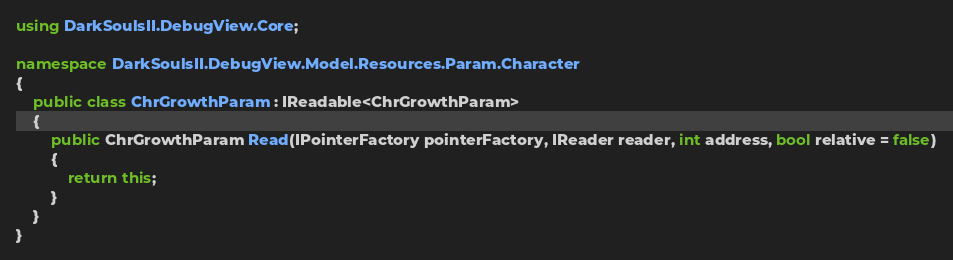Convert code to text. <code><loc_0><loc_0><loc_500><loc_500><_C#_>using DarkSoulsII.DebugView.Core;

namespace DarkSoulsII.DebugView.Model.Resources.Param.Character
{
    public class ChrGrowthParam : IReadable<ChrGrowthParam>
    {
        public ChrGrowthParam Read(IPointerFactory pointerFactory, IReader reader, int address, bool relative = false)
        {
            return this;
        }
    }
}
</code> 